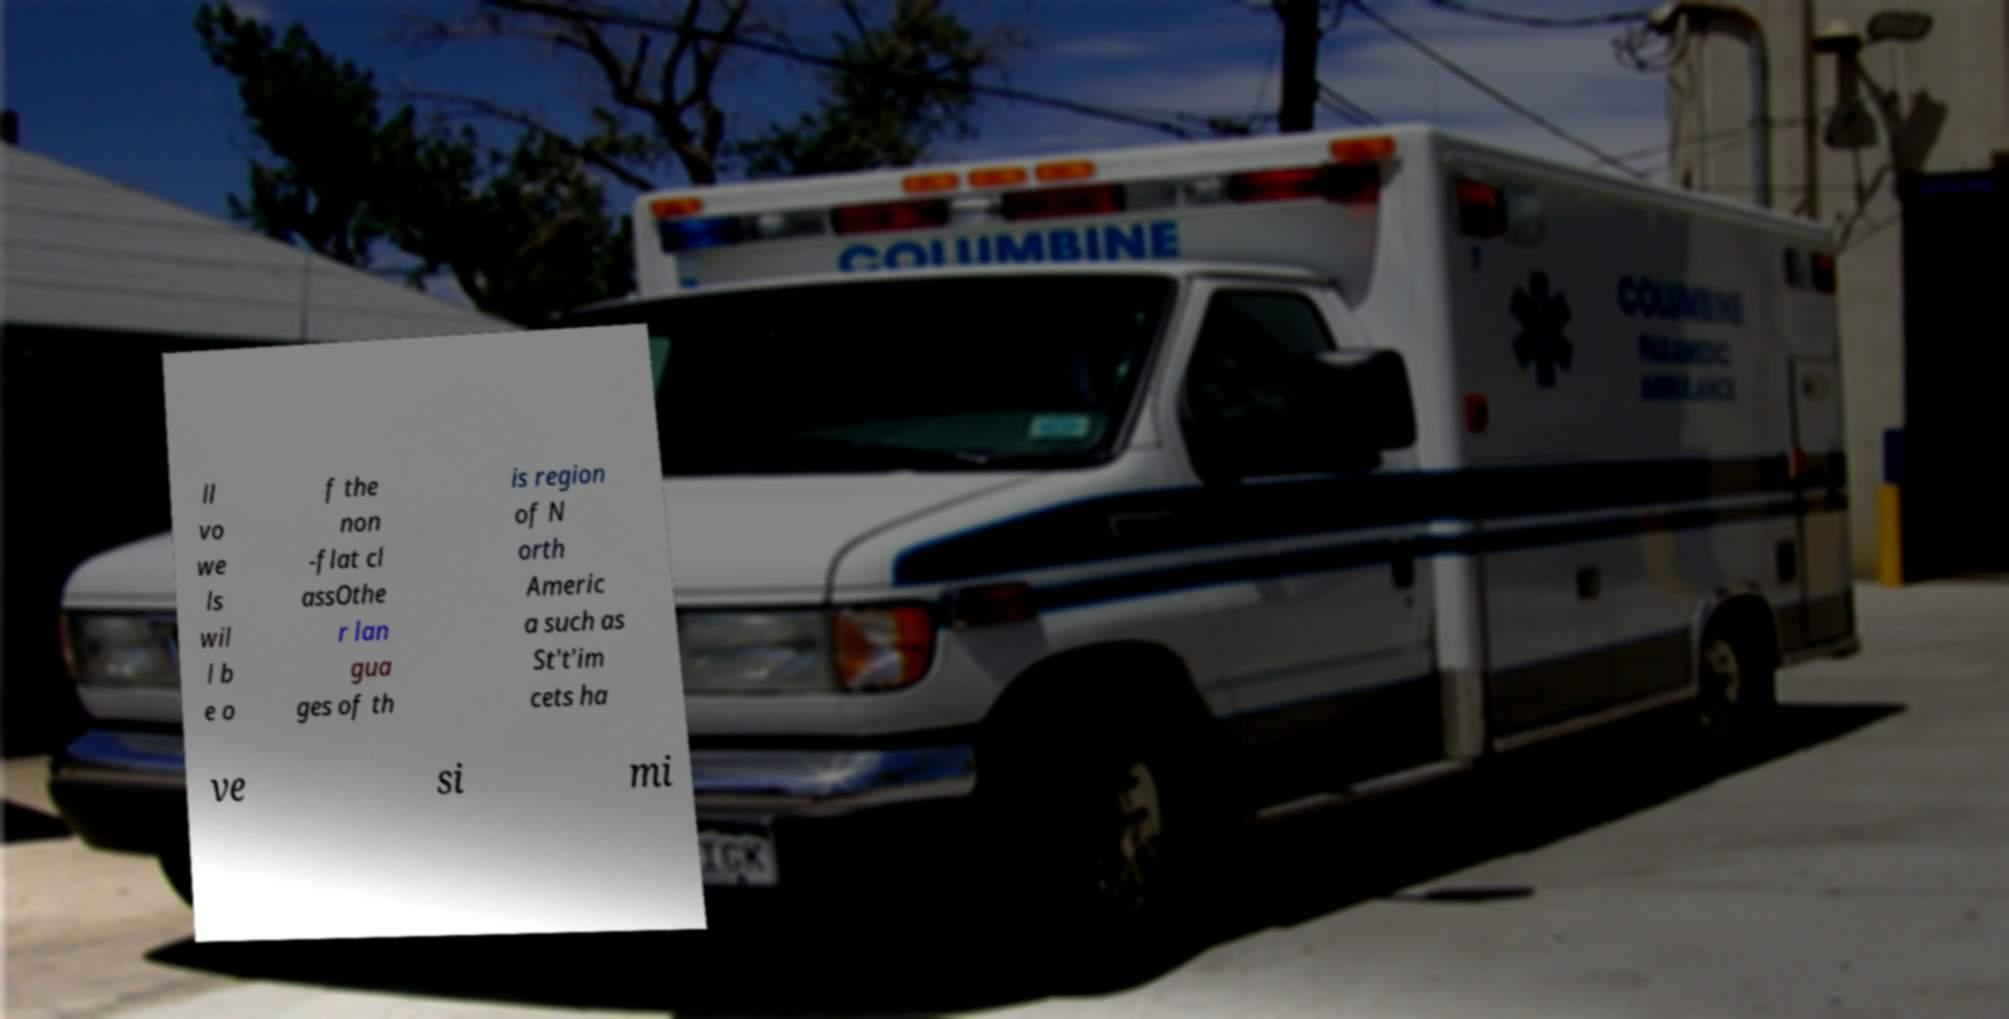Could you extract and type out the text from this image? ll vo we ls wil l b e o f the non -flat cl assOthe r lan gua ges of th is region of N orth Americ a such as St't'im cets ha ve si mi 